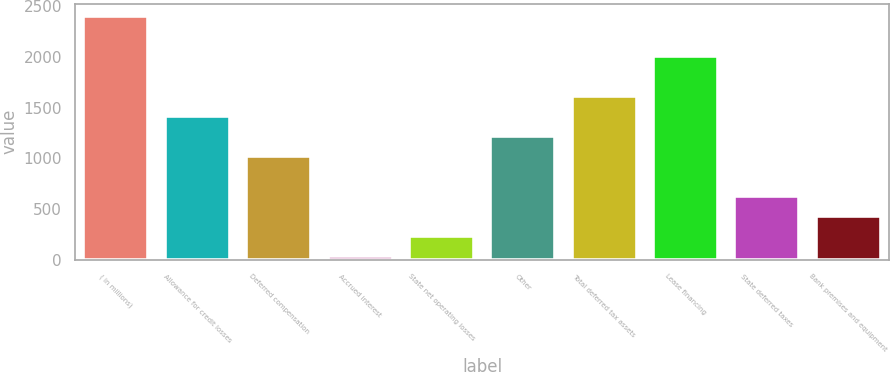Convert chart to OTSL. <chart><loc_0><loc_0><loc_500><loc_500><bar_chart><fcel>( in millions)<fcel>Allowance for credit losses<fcel>Deferred compensation<fcel>Accrued interest<fcel>State net operating losses<fcel>Other<fcel>Total deferred tax assets<fcel>Lease financing<fcel>State deferred taxes<fcel>Bank premises and equipment<nl><fcel>2401.8<fcel>1414.8<fcel>1020<fcel>33<fcel>230.4<fcel>1217.4<fcel>1612.2<fcel>2007<fcel>625.2<fcel>427.8<nl></chart> 